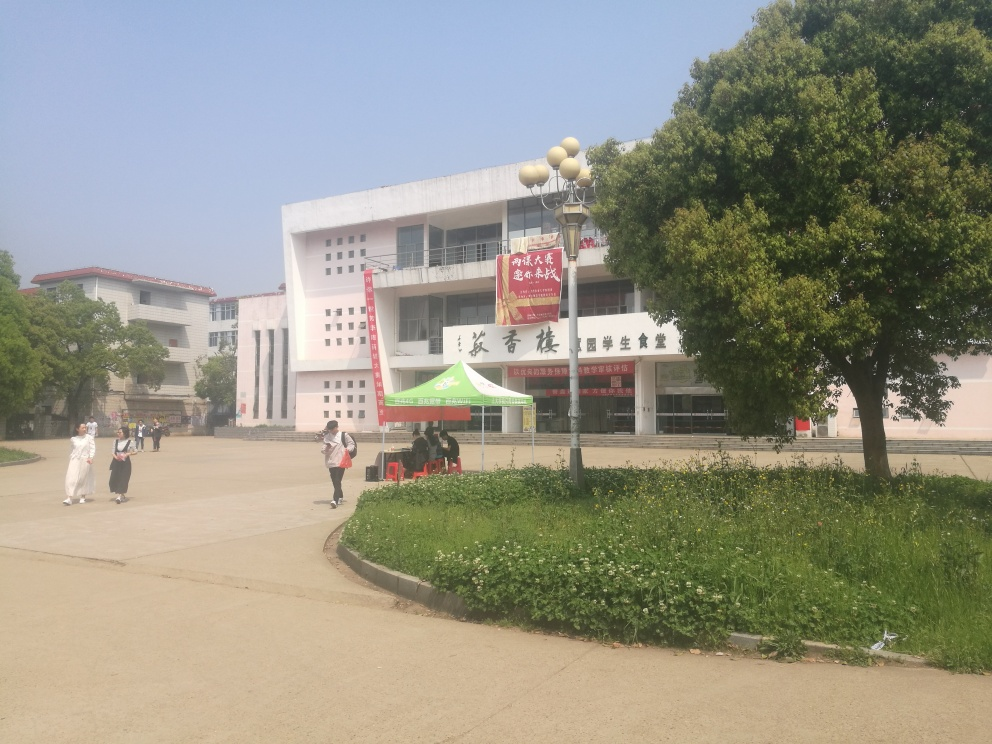What could be the function of the building shown in the image based on its design and the banners in front? The design suggests that the building serves a public or institutional purpose. The banners in front of the building suggest that there may be an ongoing event or announcement, which could indicate that the building is used for community gatherings, educational purposes, or as an administrative center. 